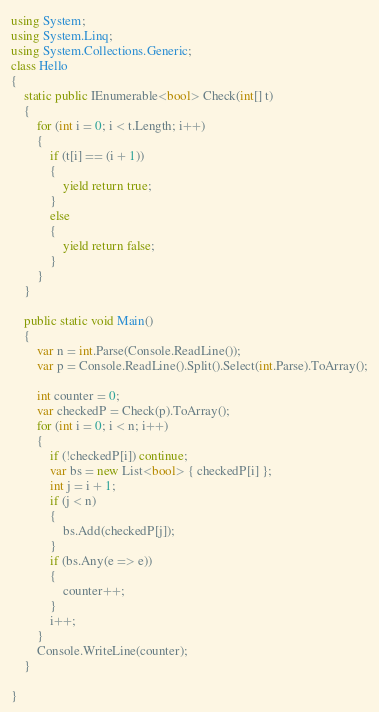<code> <loc_0><loc_0><loc_500><loc_500><_C#_>using System;
using System.Linq;
using System.Collections.Generic;
class Hello
{
    static public IEnumerable<bool> Check(int[] t)
    {
        for (int i = 0; i < t.Length; i++)
        {
            if (t[i] == (i + 1))
            {
                yield return true;
            }
            else
            {
                yield return false;
            }
        }
    }

    public static void Main()
    {
        var n = int.Parse(Console.ReadLine());
        var p = Console.ReadLine().Split().Select(int.Parse).ToArray();

        int counter = 0;
        var checkedP = Check(p).ToArray();
        for (int i = 0; i < n; i++)
        {
            if (!checkedP[i]) continue;
            var bs = new List<bool> { checkedP[i] };
            int j = i + 1;
            if (j < n)
            {
                bs.Add(checkedP[j]);
            }
            if (bs.Any(e => e))
            {
                counter++;
            }
            i++;
        }
        Console.WriteLine(counter);
    }

}</code> 